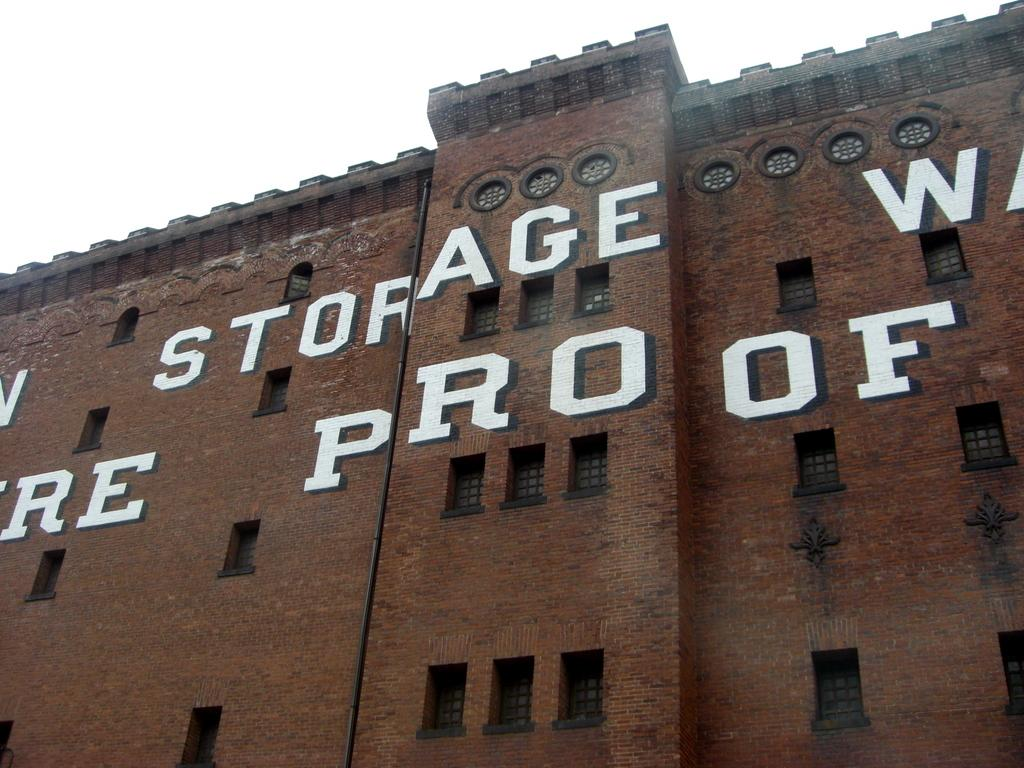What type of structure is in the image? There is a building in the image. What is the color and material of the wall of the building? The wall of the building is made of red bricks. What is written or painted on the wall of the building? There is text painted on the wall of the building. What can be seen at the top of the image? The sky is visible at the top of the image. How deep is the hole in the building's foundation in the image? There is no hole in the building's foundation visible in the image. 